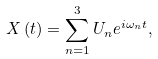Convert formula to latex. <formula><loc_0><loc_0><loc_500><loc_500>X \left ( t \right ) = \sum _ { n = 1 } ^ { 3 } U _ { n } e ^ { i \omega _ { n } t } ,</formula> 